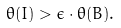<formula> <loc_0><loc_0><loc_500><loc_500>\theta ( I ) > \epsilon \cdot \theta ( B ) .</formula> 